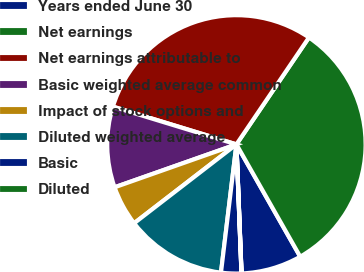Convert chart to OTSL. <chart><loc_0><loc_0><loc_500><loc_500><pie_chart><fcel>Years ended June 30<fcel>Net earnings<fcel>Net earnings attributable to<fcel>Basic weighted average common<fcel>Impact of stock options and<fcel>Diluted weighted average<fcel>Basic<fcel>Diluted<nl><fcel>7.59%<fcel>32.29%<fcel>29.77%<fcel>10.11%<fcel>5.06%<fcel>12.64%<fcel>2.53%<fcel>0.01%<nl></chart> 